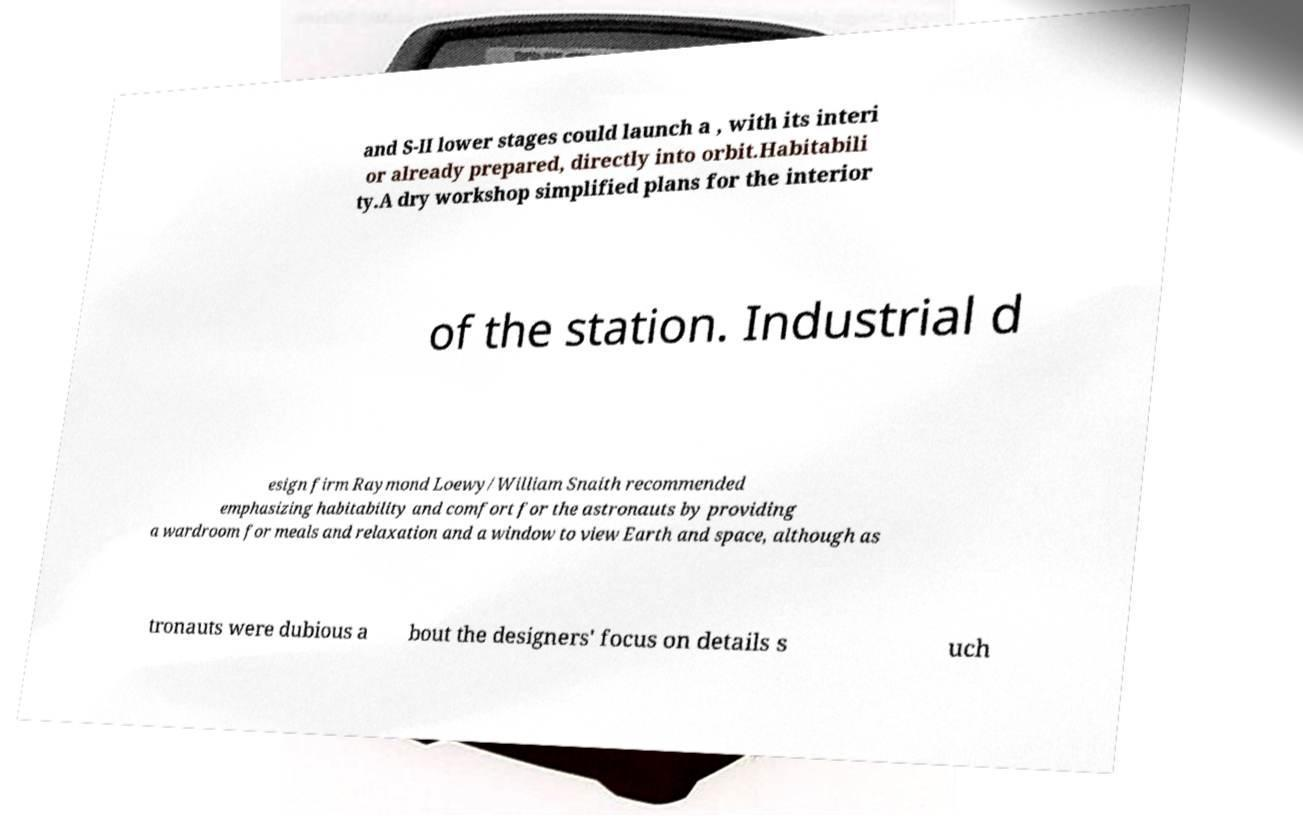I need the written content from this picture converted into text. Can you do that? and S-II lower stages could launch a , with its interi or already prepared, directly into orbit.Habitabili ty.A dry workshop simplified plans for the interior of the station. Industrial d esign firm Raymond Loewy/William Snaith recommended emphasizing habitability and comfort for the astronauts by providing a wardroom for meals and relaxation and a window to view Earth and space, although as tronauts were dubious a bout the designers' focus on details s uch 